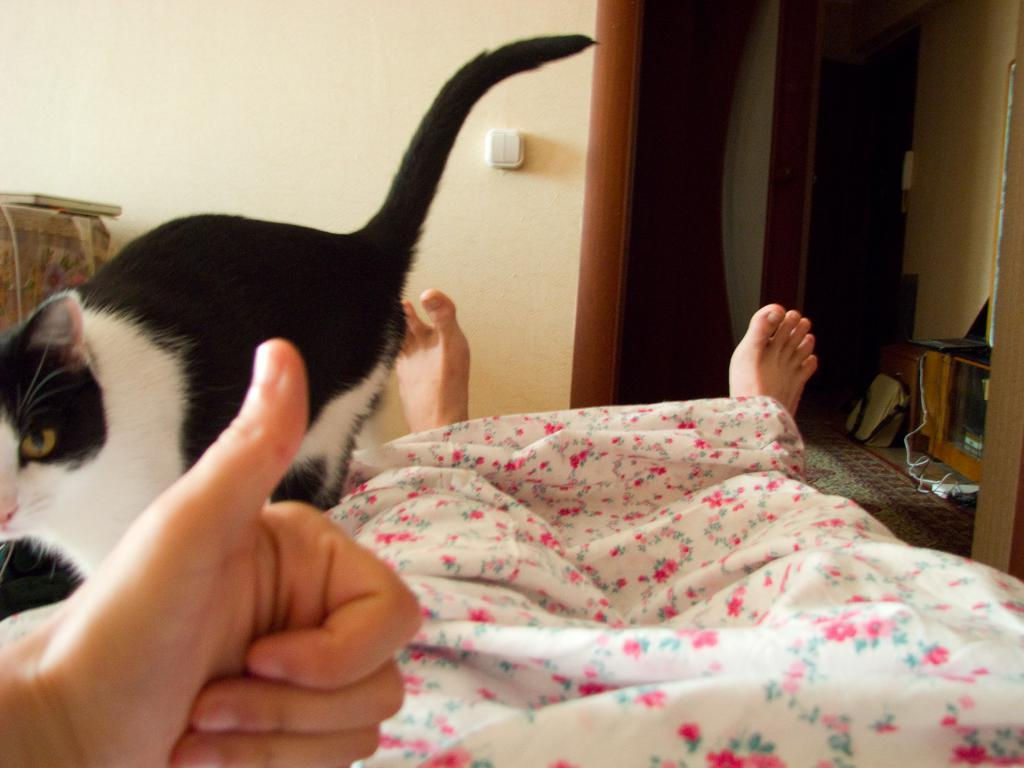What type of animal is present in the image? There is a cat in the image. Can you describe the cat's appearance? The cat is white and black in color. What else can be seen in the image besides the cat? There is a human and a blanket in the image. What is on the floor in the image? There is a bag on the floor in the image. What type of shock can be seen on the cat's face in the image? There is no shock visible on the cat's face in the image; it is simply a white and black cat. 